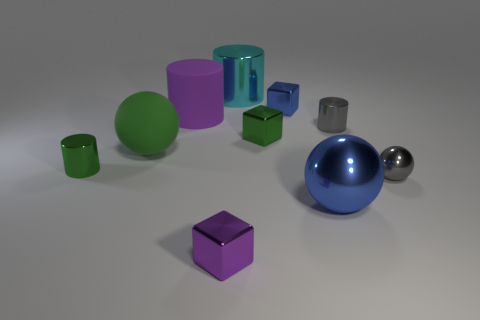How might shadows play a role in determining the spatial relationship between the objects? The shadows in the image help to establish the placement of objects in relation to the light source and to one another. For example, the length and direction of a shadow can tell us how far an object is from the surface it's resting on and its relative position to the light. By carefully examining these shadows, we can deduce that the light source is coming from the upper left and somewhat in front of the scene, and objects with more pronounced shadows are closer to the light source, adding depth to our perception of the spatial arrangement. 